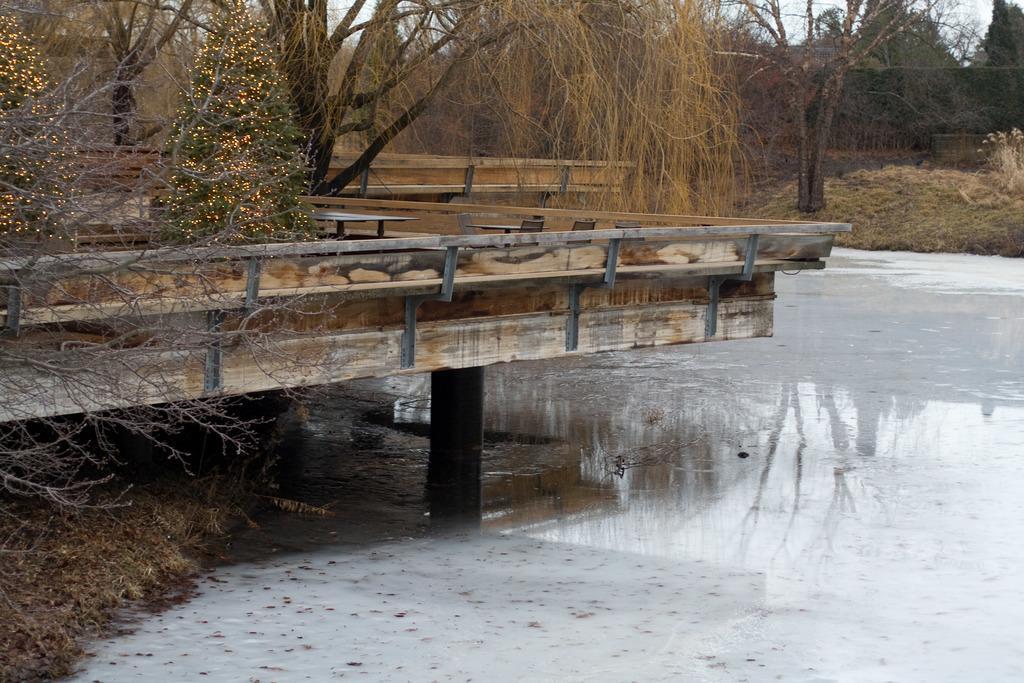Could you give a brief overview of what you see in this image? In this image there is a wooden bridge over the water, there are trees, grass and the sky. 